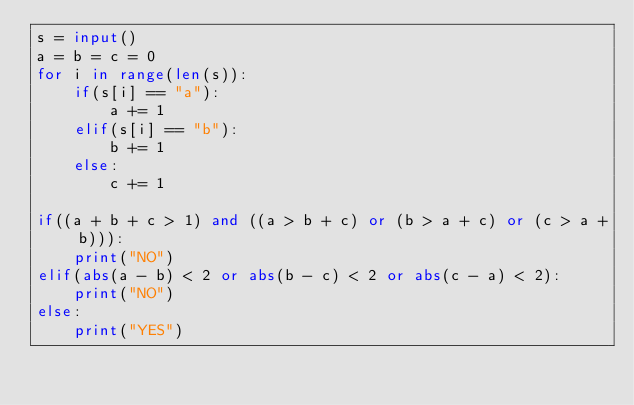Convert code to text. <code><loc_0><loc_0><loc_500><loc_500><_Python_>s = input()
a = b = c = 0
for i in range(len(s)):
    if(s[i] == "a"):
        a += 1
    elif(s[i] == "b"):
        b += 1
    else:
        c += 1
        
if((a + b + c > 1) and ((a > b + c) or (b > a + c) or (c > a + b))):
    print("NO")
elif(abs(a - b) < 2 or abs(b - c) < 2 or abs(c - a) < 2):
    print("NO")
else:
    print("YES")</code> 